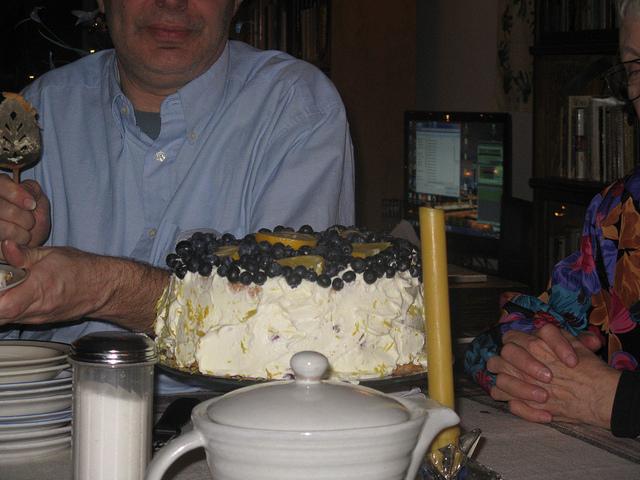What material are their pots made of?
Answer briefly. Ceramic. What event is this for?
Quick response, please. Birthday. What is the type of cake?
Answer briefly. Fruit. What is the glass jar holding?
Keep it brief. Sugar. Is that cake healthy?
Answer briefly. No. Is there fruit on this cake?
Short answer required. Yes. What is in the bottle?
Give a very brief answer. Sugar. What type of fruit is on the cake?
Write a very short answer. Blueberries. 